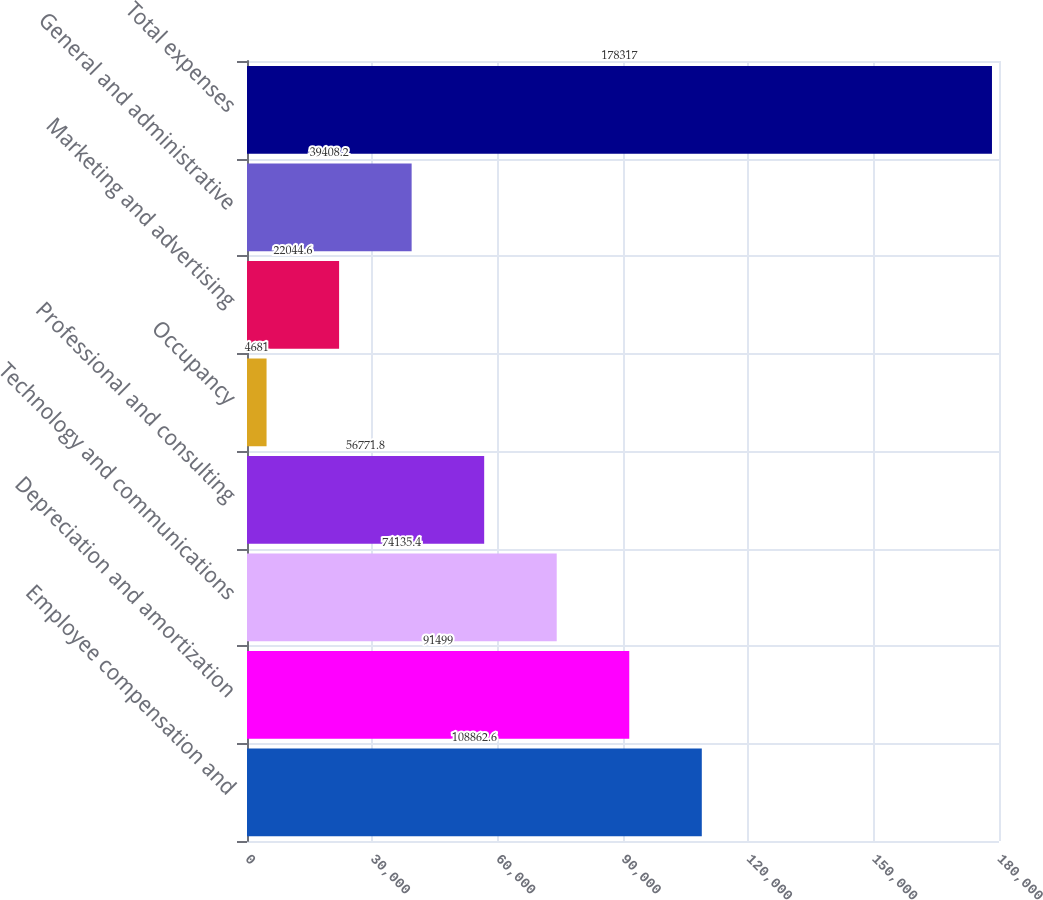Convert chart. <chart><loc_0><loc_0><loc_500><loc_500><bar_chart><fcel>Employee compensation and<fcel>Depreciation and amortization<fcel>Technology and communications<fcel>Professional and consulting<fcel>Occupancy<fcel>Marketing and advertising<fcel>General and administrative<fcel>Total expenses<nl><fcel>108863<fcel>91499<fcel>74135.4<fcel>56771.8<fcel>4681<fcel>22044.6<fcel>39408.2<fcel>178317<nl></chart> 